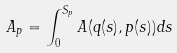Convert formula to latex. <formula><loc_0><loc_0><loc_500><loc_500>A _ { p } = \int _ { 0 } ^ { S _ { p } } A ( { q } ( s ) , { p } ( s ) ) d s</formula> 